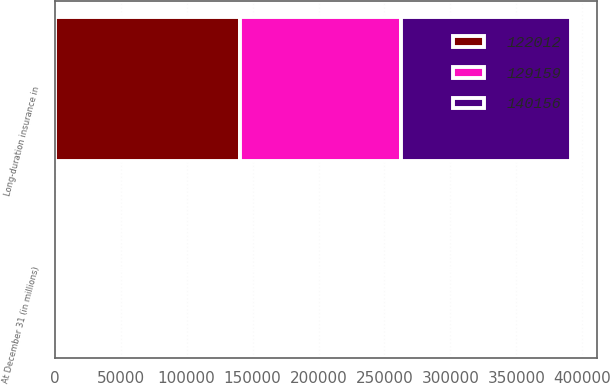<chart> <loc_0><loc_0><loc_500><loc_500><stacked_bar_chart><ecel><fcel>At December 31 (in millions)<fcel>Long-duration insurance in<nl><fcel>129159<fcel>2013<fcel>122012<nl><fcel>140156<fcel>2012<fcel>129159<nl><fcel>122012<fcel>2011<fcel>140156<nl></chart> 